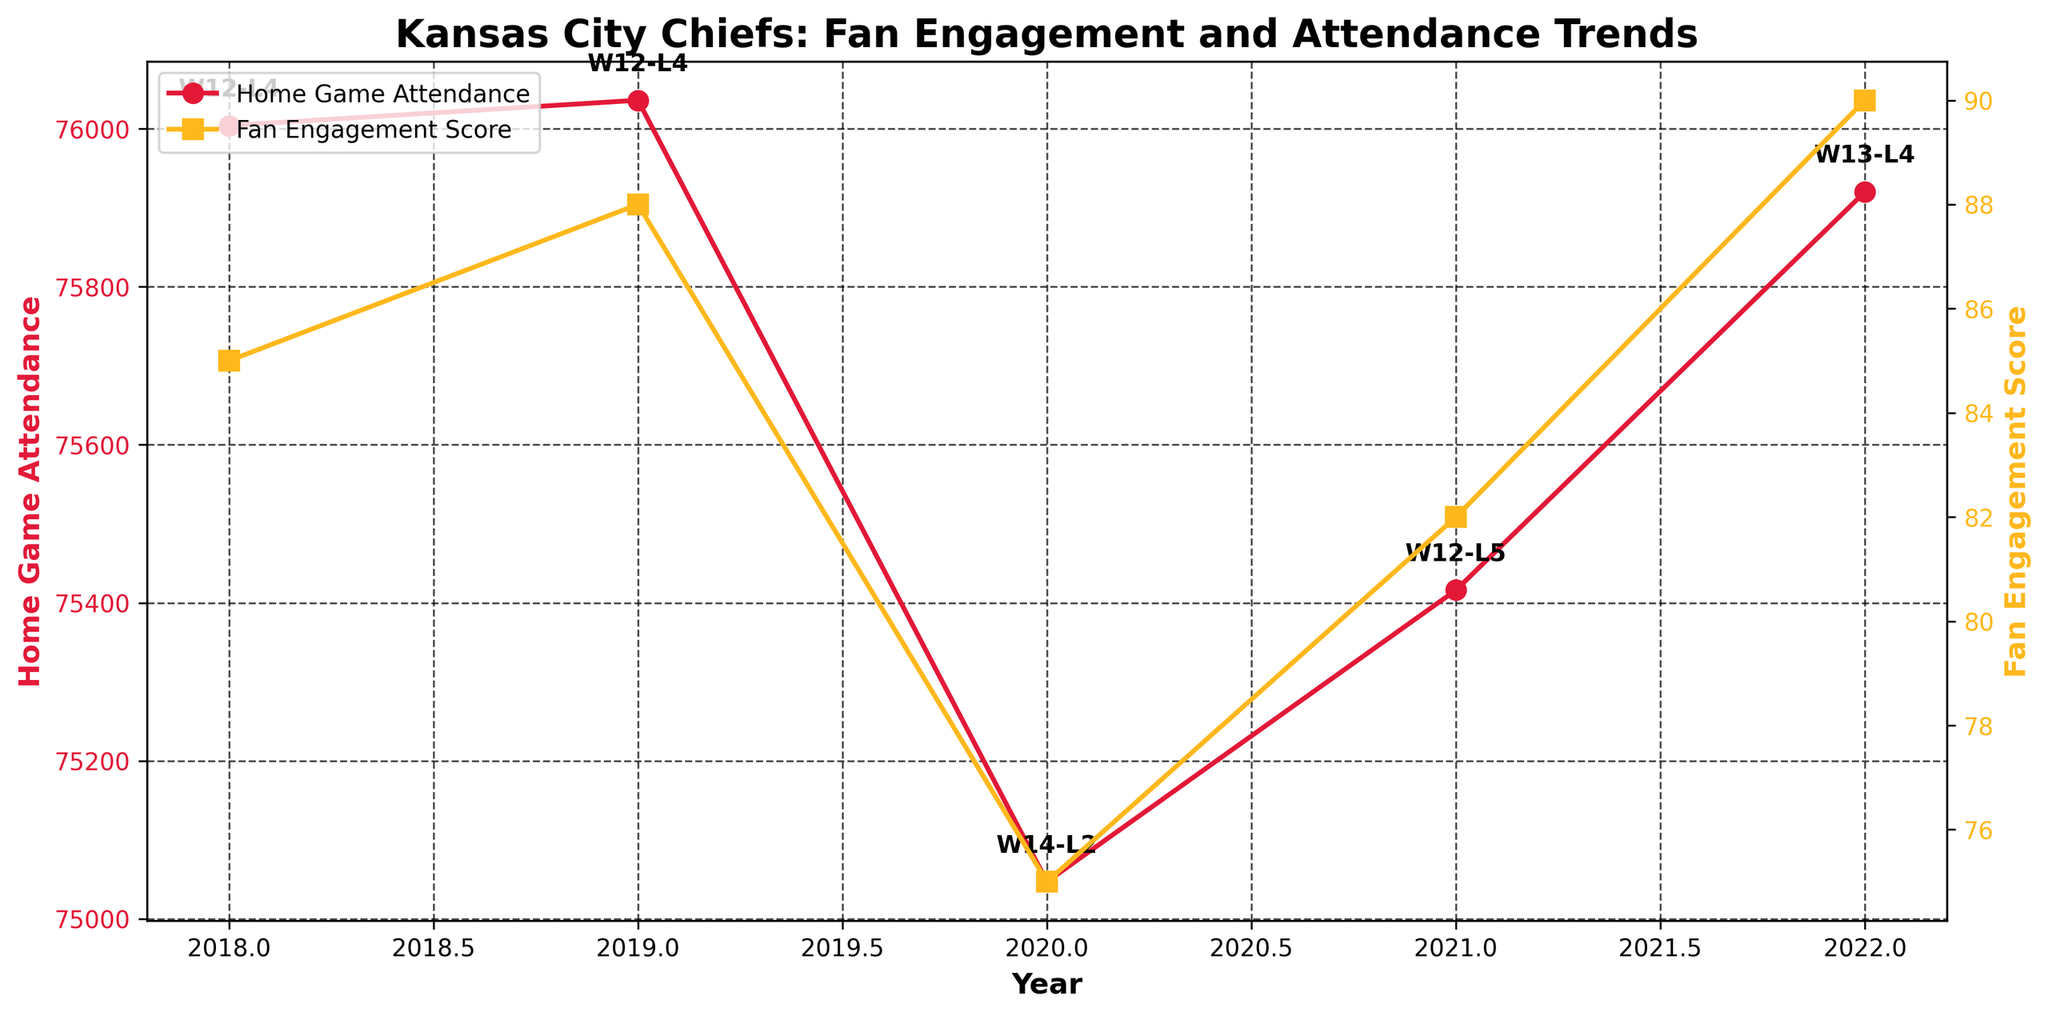What's the title of the figure? The title is located at the top of the figure and is typically in a larger and bolder font.
Answer: Kansas City Chiefs: Fan Engagement and Attendance Trends What are the colors used for the Home Game Attendance and Fan Engagement Score lines? The Home Game Attendance line is in a red hue, often used to stand out distinctly, and the Fan Engagement Score line is in a yellow hue, which is also highly visible.
Answer: Red and Yellow How many data points are shown in the figure? Each year from the dataset corresponds to a data point. There are labeled years from 2018 to 2022, inclusive.
Answer: 5 What was the Fan Engagement Score in 2020? Locate the 2020 data point along the x-axis and check the corresponding y-value on the right y-axis for the Fan Engagement Score.
Answer: 75 Which year had the highest Home Game Attendance? Look at the y-values for Home Game Attendance and identify which year reaches the highest point.
Answer: 2019 How did the Home Game Attendance change from 2019 to 2020? Check the Home Game Attendance values for 2019 and 2020 and calculate the difference by subtracting 2020's value from 2019's value.
Answer: Decreased by 989 What is the average Fan Engagement Score over the five years? Sum the Fan Engagement Scores for each year (85 + 88 + 75 + 82 + 90) and divide by the number of years (5).
Answer: 84 In which year did the Fan Engagement Score and Home Game Attendance both show an increase compared to the previous year? Compare year-to-year changes in both metrics. Identify the year where both metrics are higher compared to the immediately preceding year.
Answer: 2022 Was the Win/Loss Record always improving over the five years? Examine the text annotations of Win/Loss Records for each year and determine if there's a trend of consistent improvement.
Answer: No How did the number of events change over the years? Refer to the number of events for each year given on the figure and observe the trend or any visible pattern.
Answer: Increased overall 